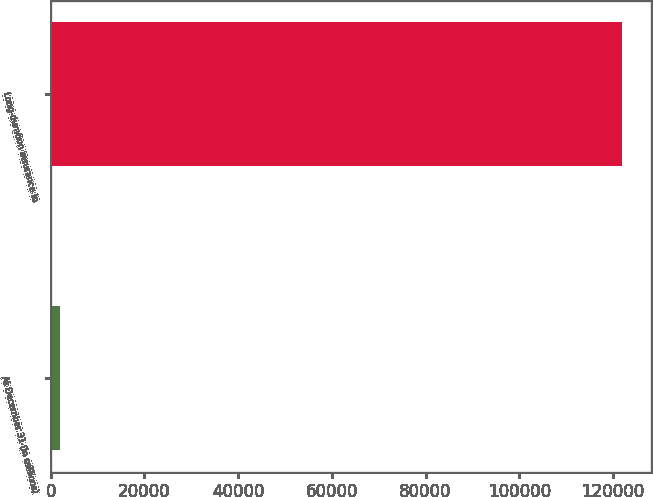Convert chart to OTSL. <chart><loc_0><loc_0><loc_500><loc_500><bar_chart><fcel>At December 31 (in millions)<fcel>Long-duration insurance in<nl><fcel>2013<fcel>122012<nl></chart> 